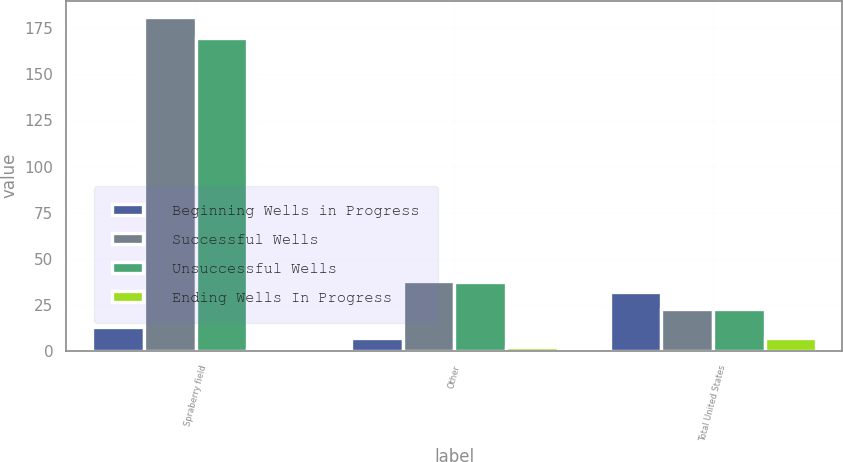Convert chart to OTSL. <chart><loc_0><loc_0><loc_500><loc_500><stacked_bar_chart><ecel><fcel>Spraberry field<fcel>Other<fcel>Total United States<nl><fcel>Beginning Wells in Progress<fcel>13<fcel>7<fcel>32<nl><fcel>Successful Wells<fcel>181<fcel>38<fcel>22.5<nl><fcel>Unsuccessful Wells<fcel>170<fcel>37<fcel>22.5<nl><fcel>Ending Wells In Progress<fcel>1<fcel>2<fcel>7<nl></chart> 